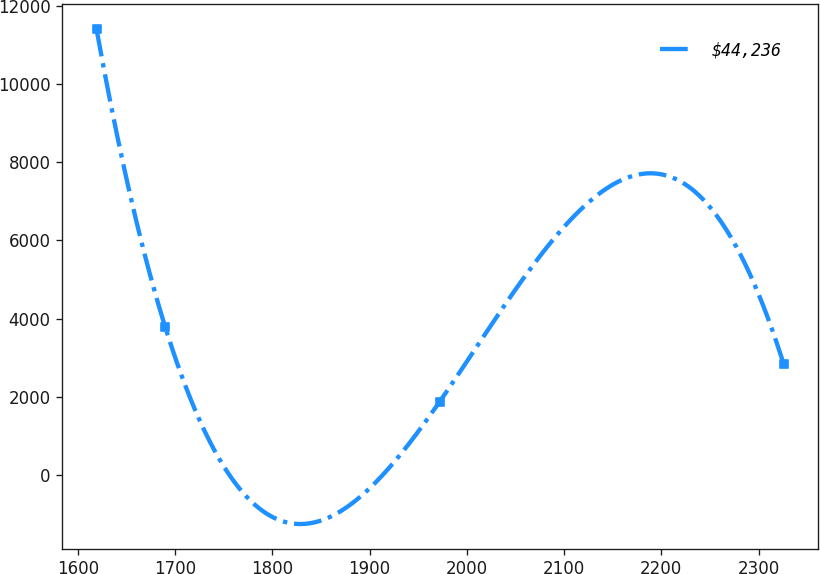Convert chart to OTSL. <chart><loc_0><loc_0><loc_500><loc_500><line_chart><ecel><fcel>$44,236<nl><fcel>1619.21<fcel>11398.4<nl><fcel>1689.88<fcel>3786.24<nl><fcel>1972.11<fcel>1883.2<nl><fcel>2325.9<fcel>2834.72<nl></chart> 